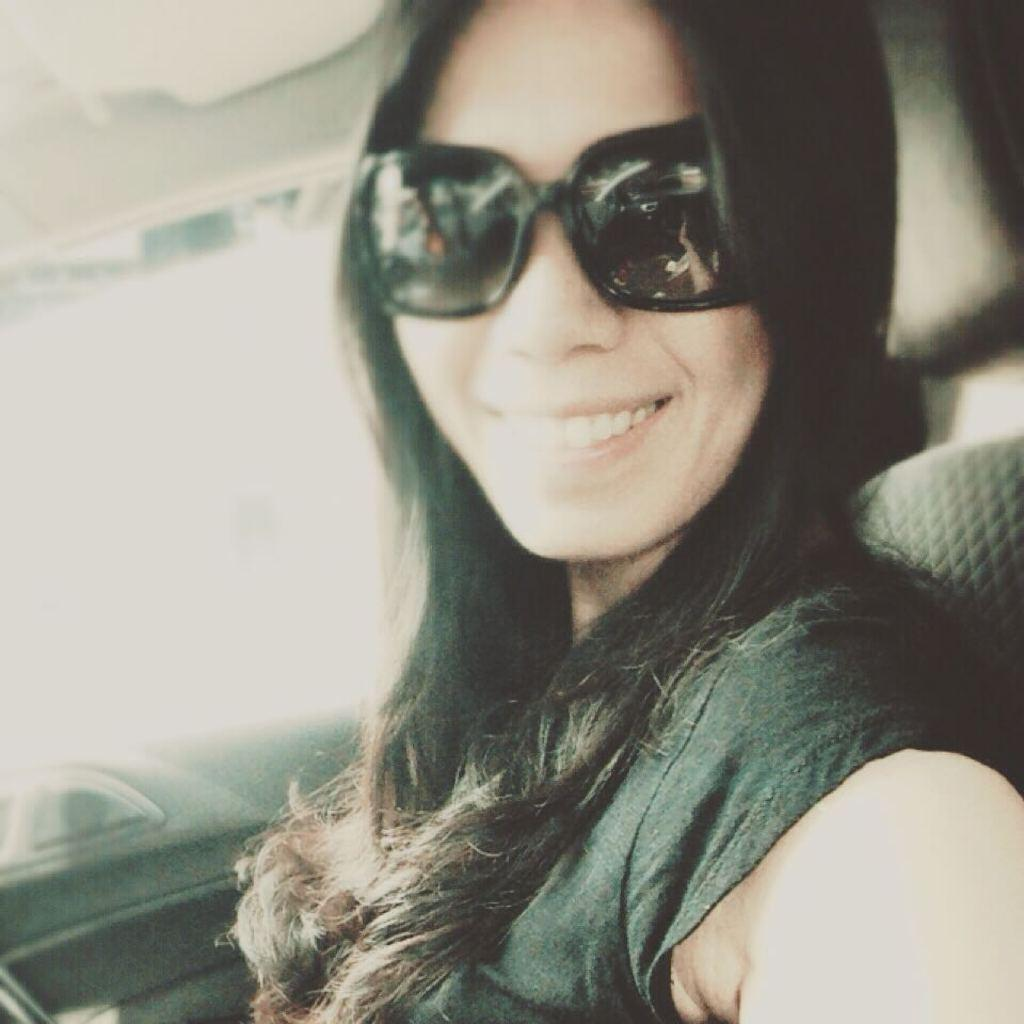Who is the main subject in the image? There is a woman in the image. What is the woman wearing on her face? The woman is wearing goggles. What is the woman's facial expression in the image? The woman is smiling. What is the woman's position in the image? The woman appears to be sitting in a vehicle. What type of frame is the woman using to swing in the image? There is no frame or swing present in the image; the woman is sitting in a vehicle. 